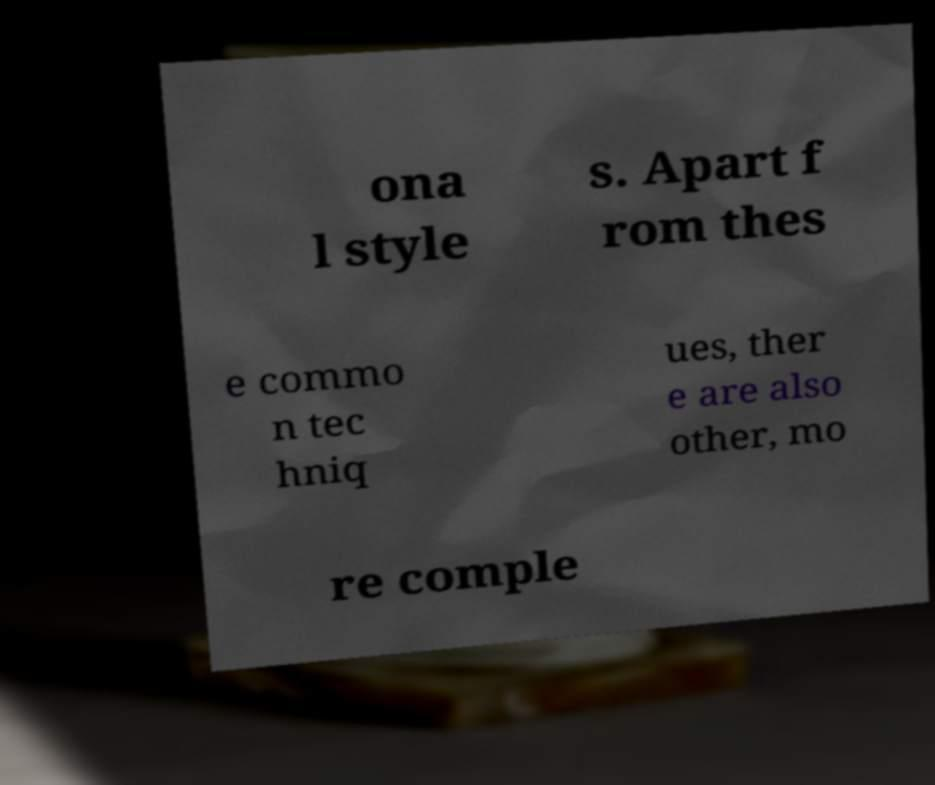Can you accurately transcribe the text from the provided image for me? ona l style s. Apart f rom thes e commo n tec hniq ues, ther e are also other, mo re comple 